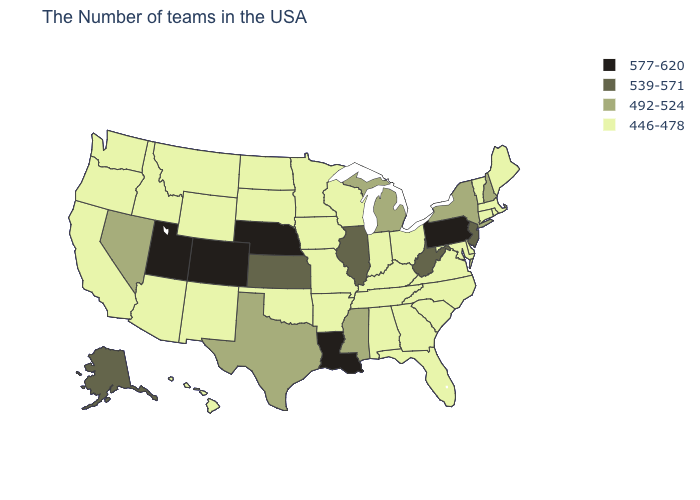What is the lowest value in states that border Rhode Island?
Short answer required. 446-478. What is the value of New Hampshire?
Short answer required. 492-524. What is the highest value in the USA?
Give a very brief answer. 577-620. Which states hav the highest value in the South?
Answer briefly. Louisiana. Name the states that have a value in the range 446-478?
Answer briefly. Maine, Massachusetts, Rhode Island, Vermont, Connecticut, Delaware, Maryland, Virginia, North Carolina, South Carolina, Ohio, Florida, Georgia, Kentucky, Indiana, Alabama, Tennessee, Wisconsin, Missouri, Arkansas, Minnesota, Iowa, Oklahoma, South Dakota, North Dakota, Wyoming, New Mexico, Montana, Arizona, Idaho, California, Washington, Oregon, Hawaii. Name the states that have a value in the range 446-478?
Quick response, please. Maine, Massachusetts, Rhode Island, Vermont, Connecticut, Delaware, Maryland, Virginia, North Carolina, South Carolina, Ohio, Florida, Georgia, Kentucky, Indiana, Alabama, Tennessee, Wisconsin, Missouri, Arkansas, Minnesota, Iowa, Oklahoma, South Dakota, North Dakota, Wyoming, New Mexico, Montana, Arizona, Idaho, California, Washington, Oregon, Hawaii. Among the states that border Rhode Island , which have the lowest value?
Write a very short answer. Massachusetts, Connecticut. What is the highest value in states that border Rhode Island?
Write a very short answer. 446-478. Among the states that border Tennessee , does Missouri have the lowest value?
Quick response, please. Yes. Name the states that have a value in the range 539-571?
Give a very brief answer. New Jersey, West Virginia, Illinois, Kansas, Alaska. Does Louisiana have the highest value in the USA?
Concise answer only. Yes. Name the states that have a value in the range 492-524?
Short answer required. New Hampshire, New York, Michigan, Mississippi, Texas, Nevada. Does the first symbol in the legend represent the smallest category?
Give a very brief answer. No. What is the value of Alabama?
Give a very brief answer. 446-478. Which states have the highest value in the USA?
Write a very short answer. Pennsylvania, Louisiana, Nebraska, Colorado, Utah. 